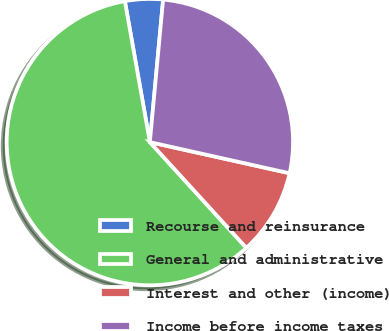Convert chart. <chart><loc_0><loc_0><loc_500><loc_500><pie_chart><fcel>Recourse and reinsurance<fcel>General and administrative<fcel>Interest and other (income)<fcel>Income before income taxes<nl><fcel>4.27%<fcel>58.97%<fcel>9.74%<fcel>27.01%<nl></chart> 